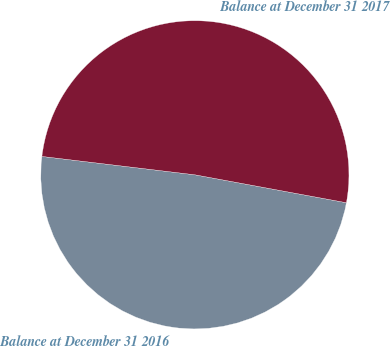<chart> <loc_0><loc_0><loc_500><loc_500><pie_chart><fcel>Balance at December 31 2016<fcel>Balance at December 31 2017<nl><fcel>49.0%<fcel>51.0%<nl></chart> 